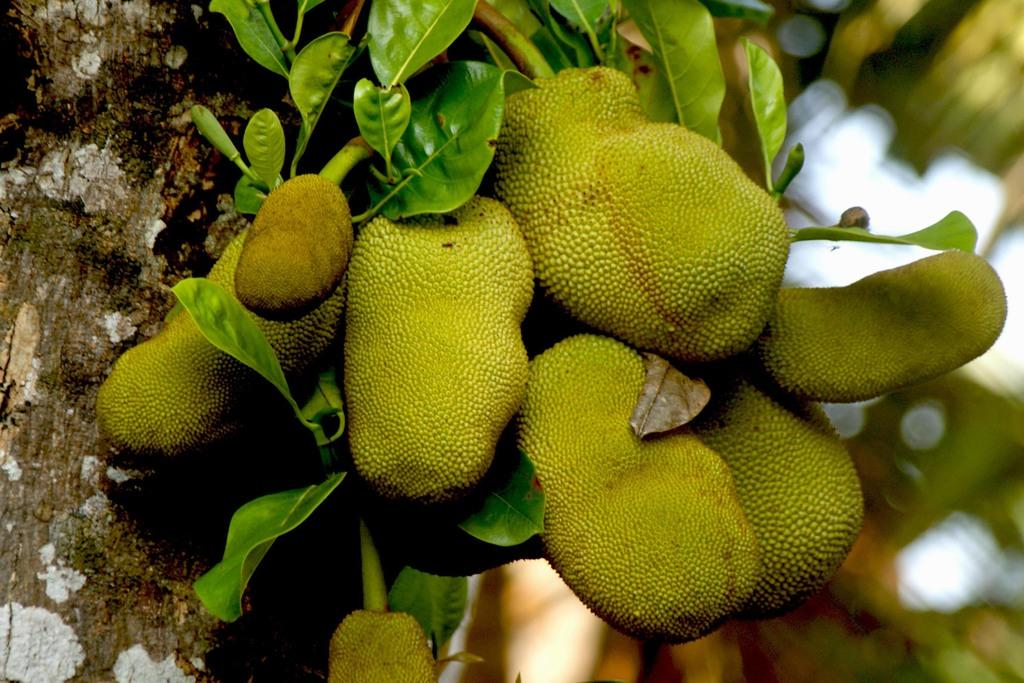What type of fruit is present in the image? There are jackfruits in the image. What is the color of the jackfruits? The jackfruits are green in color. What can be seen on the left side of the image? There is a tree on the left side of the image. How would you describe the background of the image? The background of the image is blurred. What is the name of the car parked near the jackfruits in the image? There is no car present in the image; it only features jackfruits, a tree, and a blurred background. 